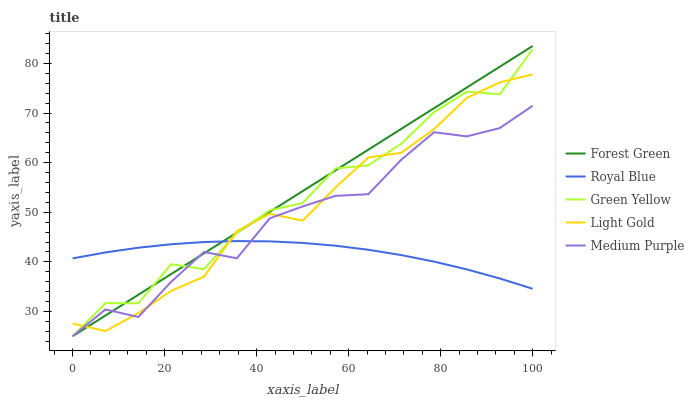Does Royal Blue have the minimum area under the curve?
Answer yes or no. Yes. Does Forest Green have the maximum area under the curve?
Answer yes or no. Yes. Does Forest Green have the minimum area under the curve?
Answer yes or no. No. Does Royal Blue have the maximum area under the curve?
Answer yes or no. No. Is Forest Green the smoothest?
Answer yes or no. Yes. Is Green Yellow the roughest?
Answer yes or no. Yes. Is Royal Blue the smoothest?
Answer yes or no. No. Is Royal Blue the roughest?
Answer yes or no. No. Does Royal Blue have the lowest value?
Answer yes or no. No. Does Royal Blue have the highest value?
Answer yes or no. No. 